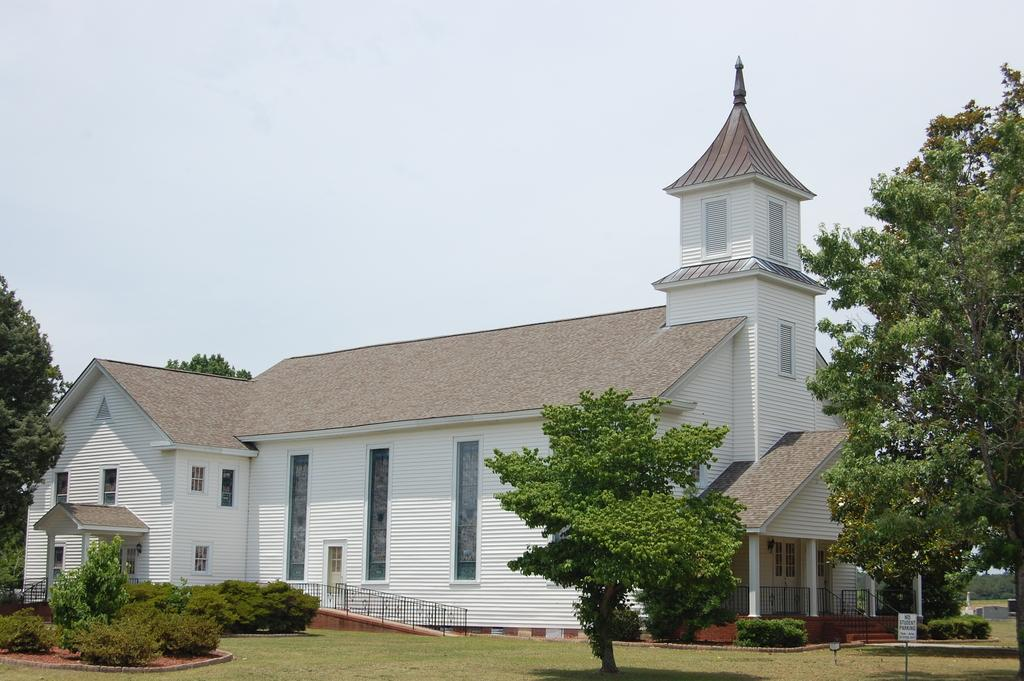What type of structure is visible in the picture? There is a house in the picture. What type of vegetation can be seen in the picture? There are trees, plants, and grass in the picture. What other objects can be seen in the picture? There is a board and railings in the picture. What part of the natural environment is visible in the picture? The sky is visible in the picture. What type of health advice is the judge giving in the picture? There is no judge or health advice present in the picture; it features a house, trees, plants, grass, a board, railings, and the sky. What color is the sock on the judge's foot in the picture? There is no judge or sock present in the picture. 